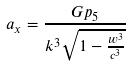Convert formula to latex. <formula><loc_0><loc_0><loc_500><loc_500>a _ { x } = \frac { G p _ { 5 } } { k ^ { 3 } \sqrt { 1 - \frac { w ^ { 3 } } { c ^ { 3 } } } }</formula> 